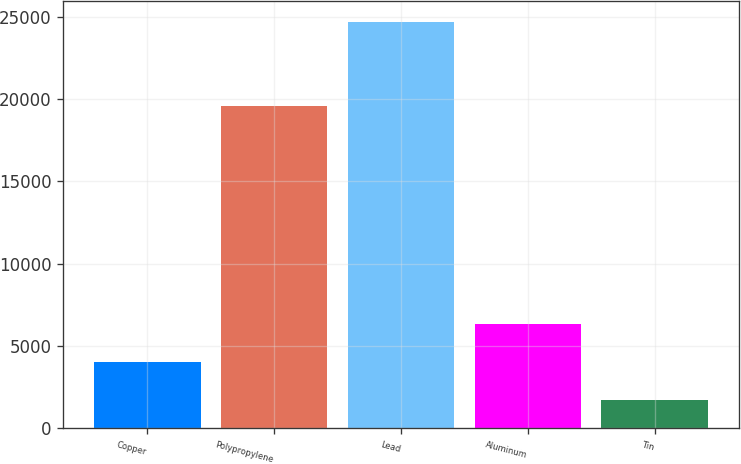Convert chart to OTSL. <chart><loc_0><loc_0><loc_500><loc_500><bar_chart><fcel>Copper<fcel>Polypropylene<fcel>Lead<fcel>Aluminum<fcel>Tin<nl><fcel>4014<fcel>19563<fcel>24705<fcel>6313<fcel>1715<nl></chart> 